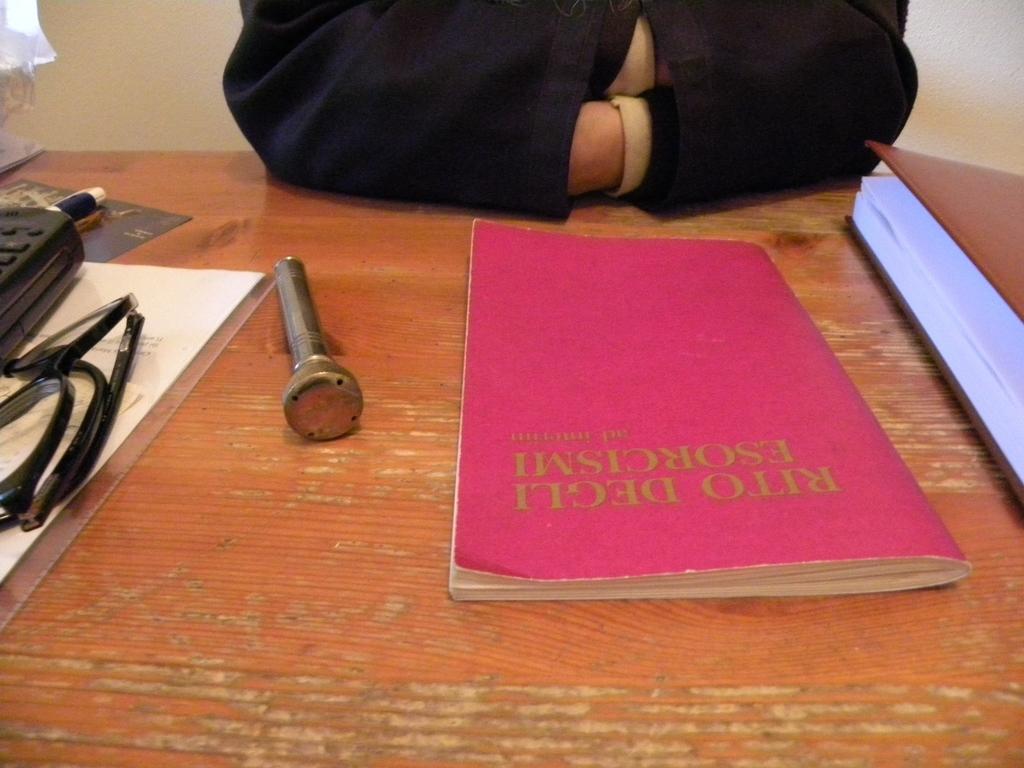What's the title of the pink book?
Give a very brief answer. Rito degli esorcismi. 